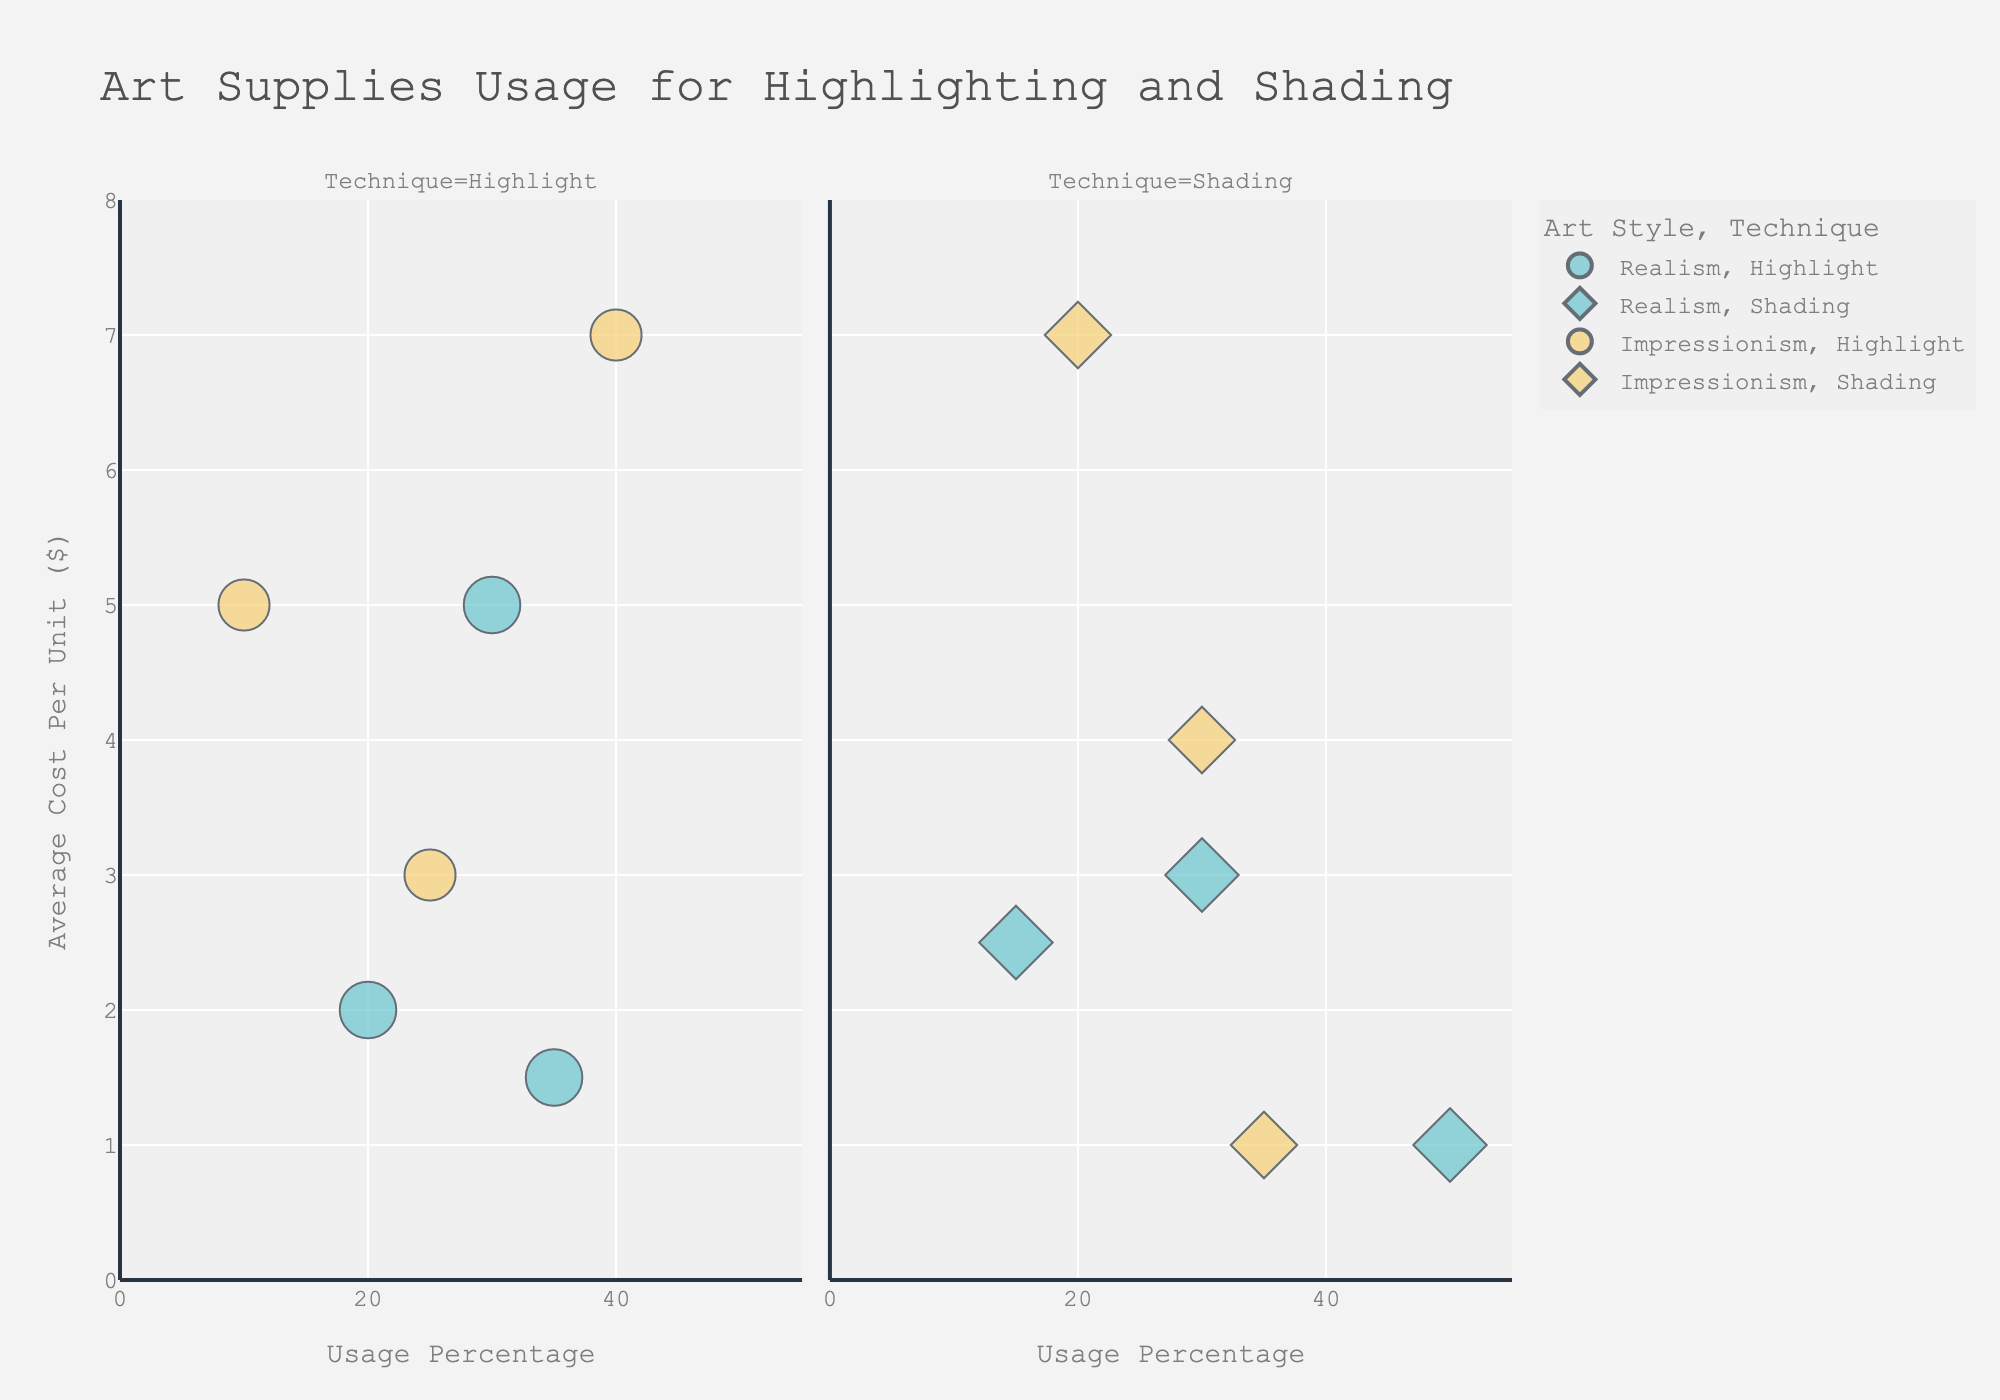what is the title of the chart? The chart's title is generally placed at the top of the figure. Here it reads: "Art Supplies Usage for Highlighting and Shading".
Answer: Art Supplies Usage for Highlighting and Shading What is the range of the x-axis? The x-axis represents 'Usage Percentage'. The customized axis range goes from 0 to 55, as indicated visually by tick marks.
Answer: 0 to 55 Which art style for Highlighting has the highest usage percentage? By observing the 'Highlight' facet and looking for the highest point on the Usage Percentage axis: it is 'Impressionism' using 'Watercolor' with 40%.
Answer: Impressionism How many artists were surveyed about Realism shading techniques? Bubble sizes are proportional to the number of artists surveyed. Checking 'Realism' under 'Shading', we see Graphite Pencil, Charcoal Block, and Ink Pen. Each has a bubble size indicating 150 artists. Summing them up: 150.
Answer: 150 Which shading supply has the lowest average cost? In the 'Shading' facet, by comparing the y-axis values under both art styles: Graphite Pencil has the lowest cost of $1.00.
Answer: Graphite Pencil What are the common supplies used for Realism highlighting and Impressionism shading? Under 'Highlight' for Realism and 'Shading' for Impressionism, the common art supplies can be inferred by item names: Graphite Pencil is used in both categories.
Answer: Graphite Pencil Which art supply used for shading in Realism has the highest usage percentage? Focusing on 'Shading' in the 'Realism' category, the highest usage percentage is Graphite Pencil with 50%.
Answer: Graphite Pencil Compare the average cost of art supplies for shading in Impressionism vs Highlighting in Realism. Look at the 'Impressionism' shading and 'Realism' highlighting facets. Using their average y-axis positions:
- Impressionism shading (Graphite Pencil $1, Soft Pastels $4, Watercolor $7): Average = (1 + 4 + 7) / 3 = $4
- Realism highlighting (White Charcoal Pencil $1.5, Gel Pen $2, Acrylic Paint $5): Average = (1.5 + 2 + 5) / 3 = $2.83
Average for impressionism shading is higher at $4.
Answer: Impressionism shading has a higher average at $4 What is the total number of artist responses featured for both techniques combined? Sum across all entries: Realism (150 each for 6 entries, 3 for highlighting and 3 for shading) and Impressionism (100 each for 6 entries, 3 for highlighting and 3 for shading): (150*6) + (100*6) = 1500
Answer: 1500 Which highlighting supply for Impressionism has the second highest usage percentage? In the 'Highlight' facet under 'Impressionism' style, sorted by usage percentage: Watercolor at 40%, next White Oil Pastel at 25%.
Answer: White Oil Pastel 